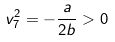<formula> <loc_0><loc_0><loc_500><loc_500>v _ { 7 } ^ { 2 } = - \frac { a } { 2 b } > 0</formula> 